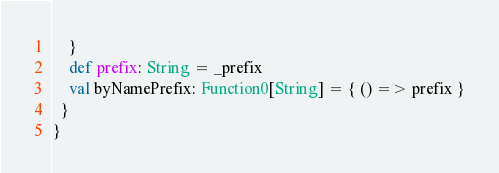Convert code to text. <code><loc_0><loc_0><loc_500><loc_500><_Scala_>    }
    def prefix: String = _prefix
    val byNamePrefix: Function0[String] = { () => prefix }
  }
}
</code> 